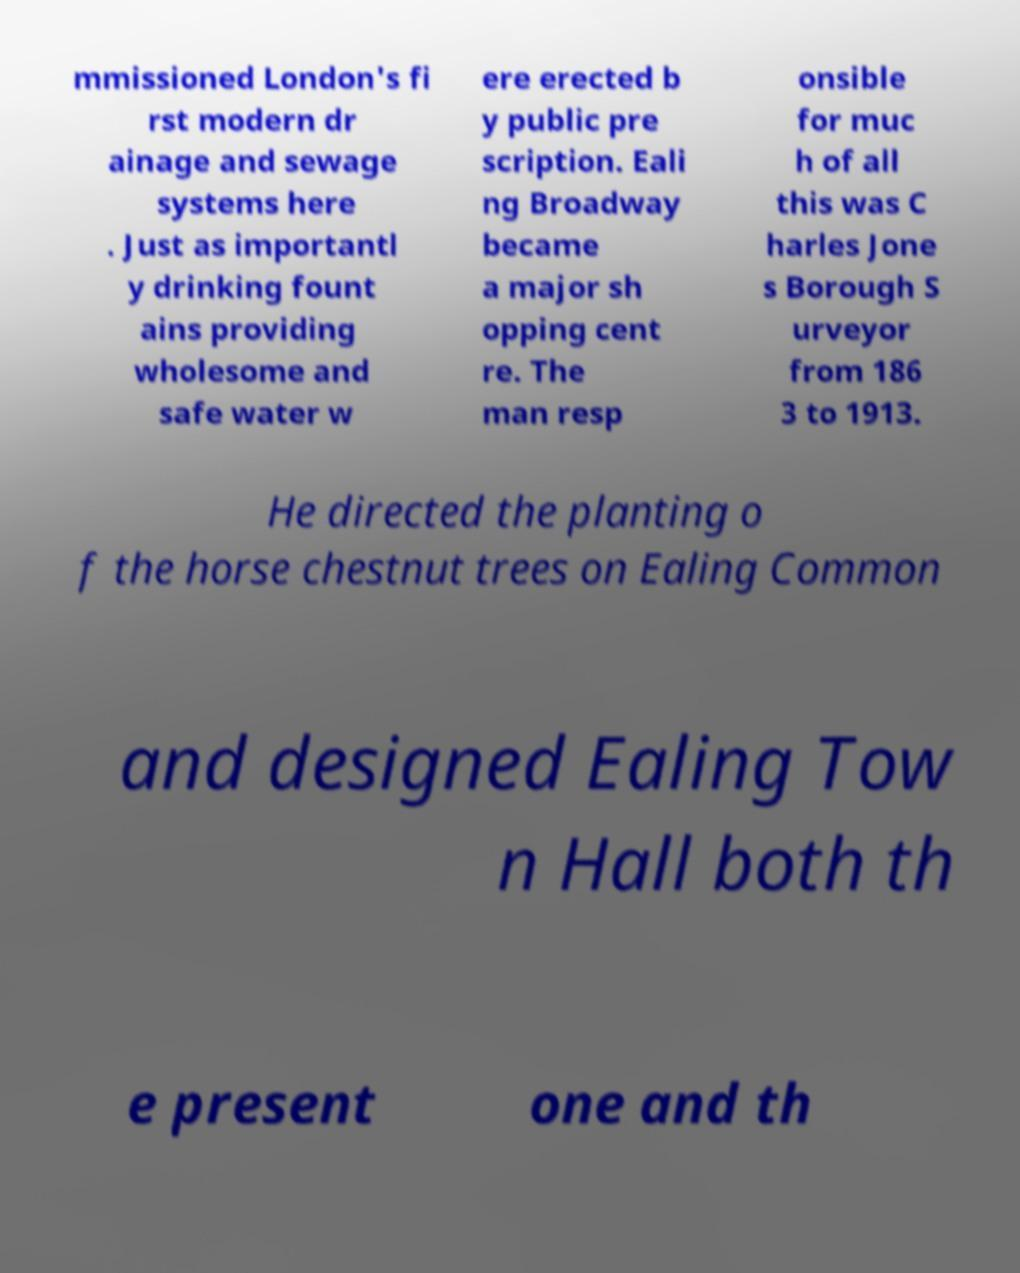Please identify and transcribe the text found in this image. mmissioned London's fi rst modern dr ainage and sewage systems here . Just as importantl y drinking fount ains providing wholesome and safe water w ere erected b y public pre scription. Eali ng Broadway became a major sh opping cent re. The man resp onsible for muc h of all this was C harles Jone s Borough S urveyor from 186 3 to 1913. He directed the planting o f the horse chestnut trees on Ealing Common and designed Ealing Tow n Hall both th e present one and th 